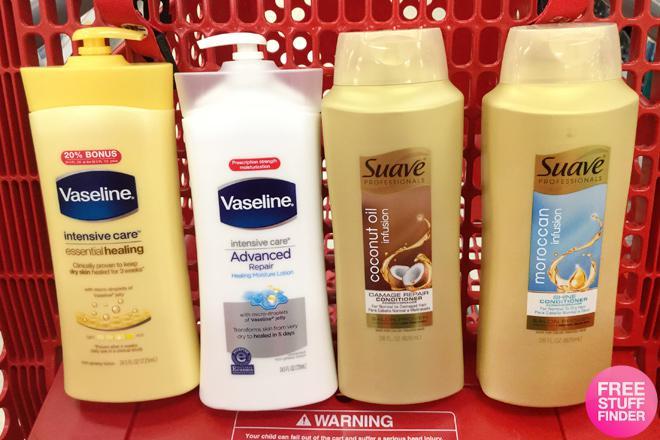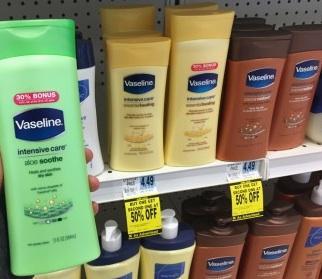The first image is the image on the left, the second image is the image on the right. Evaluate the accuracy of this statement regarding the images: "There is a hand holding product next to the shelf that shows the sales prices, on the wrist is a watch". Is it true? Answer yes or no. No. The first image is the image on the left, the second image is the image on the right. For the images shown, is this caption "Some price tags are green." true? Answer yes or no. No. 